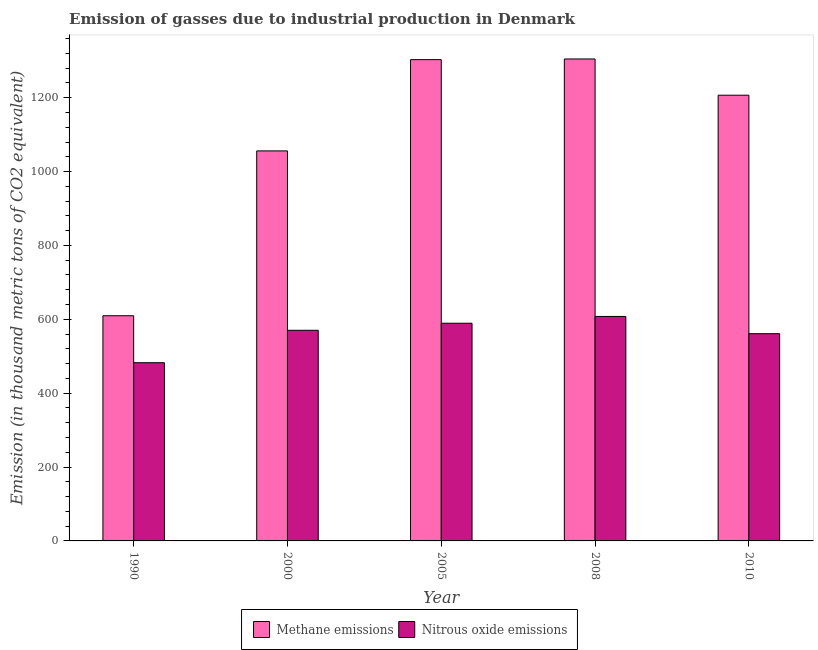How many different coloured bars are there?
Offer a very short reply. 2. How many groups of bars are there?
Make the answer very short. 5. Are the number of bars per tick equal to the number of legend labels?
Keep it short and to the point. Yes. How many bars are there on the 2nd tick from the left?
Provide a succinct answer. 2. What is the label of the 3rd group of bars from the left?
Give a very brief answer. 2005. What is the amount of methane emissions in 2010?
Provide a succinct answer. 1206.8. Across all years, what is the maximum amount of methane emissions?
Your response must be concise. 1304.9. Across all years, what is the minimum amount of nitrous oxide emissions?
Offer a very short reply. 482.5. In which year was the amount of methane emissions minimum?
Offer a very short reply. 1990. What is the total amount of nitrous oxide emissions in the graph?
Offer a very short reply. 2811.1. What is the difference between the amount of nitrous oxide emissions in 2005 and that in 2010?
Make the answer very short. 28.3. What is the difference between the amount of nitrous oxide emissions in 2000 and the amount of methane emissions in 2005?
Your response must be concise. -19.1. What is the average amount of methane emissions per year?
Your response must be concise. 1096.1. What is the ratio of the amount of methane emissions in 2000 to that in 2010?
Keep it short and to the point. 0.88. Is the amount of methane emissions in 2000 less than that in 2008?
Your answer should be very brief. Yes. Is the difference between the amount of nitrous oxide emissions in 1990 and 2008 greater than the difference between the amount of methane emissions in 1990 and 2008?
Ensure brevity in your answer.  No. What is the difference between the highest and the second highest amount of nitrous oxide emissions?
Your response must be concise. 18.4. What is the difference between the highest and the lowest amount of methane emissions?
Offer a very short reply. 695.2. In how many years, is the amount of nitrous oxide emissions greater than the average amount of nitrous oxide emissions taken over all years?
Provide a short and direct response. 3. Is the sum of the amount of nitrous oxide emissions in 2000 and 2008 greater than the maximum amount of methane emissions across all years?
Provide a succinct answer. Yes. What does the 2nd bar from the left in 2000 represents?
Ensure brevity in your answer.  Nitrous oxide emissions. What does the 2nd bar from the right in 2010 represents?
Offer a very short reply. Methane emissions. How many bars are there?
Make the answer very short. 10. What is the difference between two consecutive major ticks on the Y-axis?
Your answer should be very brief. 200. Are the values on the major ticks of Y-axis written in scientific E-notation?
Your answer should be very brief. No. Does the graph contain any zero values?
Your response must be concise. No. Does the graph contain grids?
Offer a very short reply. No. Where does the legend appear in the graph?
Give a very brief answer. Bottom center. What is the title of the graph?
Offer a terse response. Emission of gasses due to industrial production in Denmark. What is the label or title of the Y-axis?
Provide a short and direct response. Emission (in thousand metric tons of CO2 equivalent). What is the Emission (in thousand metric tons of CO2 equivalent) of Methane emissions in 1990?
Your answer should be very brief. 609.7. What is the Emission (in thousand metric tons of CO2 equivalent) in Nitrous oxide emissions in 1990?
Offer a very short reply. 482.5. What is the Emission (in thousand metric tons of CO2 equivalent) of Methane emissions in 2000?
Offer a very short reply. 1056. What is the Emission (in thousand metric tons of CO2 equivalent) in Nitrous oxide emissions in 2000?
Your answer should be very brief. 570.3. What is the Emission (in thousand metric tons of CO2 equivalent) in Methane emissions in 2005?
Offer a terse response. 1303.1. What is the Emission (in thousand metric tons of CO2 equivalent) of Nitrous oxide emissions in 2005?
Your response must be concise. 589.4. What is the Emission (in thousand metric tons of CO2 equivalent) in Methane emissions in 2008?
Give a very brief answer. 1304.9. What is the Emission (in thousand metric tons of CO2 equivalent) in Nitrous oxide emissions in 2008?
Provide a succinct answer. 607.8. What is the Emission (in thousand metric tons of CO2 equivalent) of Methane emissions in 2010?
Your answer should be very brief. 1206.8. What is the Emission (in thousand metric tons of CO2 equivalent) of Nitrous oxide emissions in 2010?
Provide a short and direct response. 561.1. Across all years, what is the maximum Emission (in thousand metric tons of CO2 equivalent) of Methane emissions?
Provide a short and direct response. 1304.9. Across all years, what is the maximum Emission (in thousand metric tons of CO2 equivalent) in Nitrous oxide emissions?
Your answer should be compact. 607.8. Across all years, what is the minimum Emission (in thousand metric tons of CO2 equivalent) in Methane emissions?
Make the answer very short. 609.7. Across all years, what is the minimum Emission (in thousand metric tons of CO2 equivalent) of Nitrous oxide emissions?
Provide a short and direct response. 482.5. What is the total Emission (in thousand metric tons of CO2 equivalent) of Methane emissions in the graph?
Make the answer very short. 5480.5. What is the total Emission (in thousand metric tons of CO2 equivalent) of Nitrous oxide emissions in the graph?
Offer a very short reply. 2811.1. What is the difference between the Emission (in thousand metric tons of CO2 equivalent) of Methane emissions in 1990 and that in 2000?
Give a very brief answer. -446.3. What is the difference between the Emission (in thousand metric tons of CO2 equivalent) of Nitrous oxide emissions in 1990 and that in 2000?
Give a very brief answer. -87.8. What is the difference between the Emission (in thousand metric tons of CO2 equivalent) in Methane emissions in 1990 and that in 2005?
Your answer should be compact. -693.4. What is the difference between the Emission (in thousand metric tons of CO2 equivalent) in Nitrous oxide emissions in 1990 and that in 2005?
Provide a short and direct response. -106.9. What is the difference between the Emission (in thousand metric tons of CO2 equivalent) of Methane emissions in 1990 and that in 2008?
Offer a terse response. -695.2. What is the difference between the Emission (in thousand metric tons of CO2 equivalent) of Nitrous oxide emissions in 1990 and that in 2008?
Your answer should be very brief. -125.3. What is the difference between the Emission (in thousand metric tons of CO2 equivalent) of Methane emissions in 1990 and that in 2010?
Offer a very short reply. -597.1. What is the difference between the Emission (in thousand metric tons of CO2 equivalent) in Nitrous oxide emissions in 1990 and that in 2010?
Give a very brief answer. -78.6. What is the difference between the Emission (in thousand metric tons of CO2 equivalent) in Methane emissions in 2000 and that in 2005?
Keep it short and to the point. -247.1. What is the difference between the Emission (in thousand metric tons of CO2 equivalent) of Nitrous oxide emissions in 2000 and that in 2005?
Give a very brief answer. -19.1. What is the difference between the Emission (in thousand metric tons of CO2 equivalent) of Methane emissions in 2000 and that in 2008?
Keep it short and to the point. -248.9. What is the difference between the Emission (in thousand metric tons of CO2 equivalent) of Nitrous oxide emissions in 2000 and that in 2008?
Offer a very short reply. -37.5. What is the difference between the Emission (in thousand metric tons of CO2 equivalent) of Methane emissions in 2000 and that in 2010?
Keep it short and to the point. -150.8. What is the difference between the Emission (in thousand metric tons of CO2 equivalent) in Nitrous oxide emissions in 2000 and that in 2010?
Your response must be concise. 9.2. What is the difference between the Emission (in thousand metric tons of CO2 equivalent) of Nitrous oxide emissions in 2005 and that in 2008?
Provide a succinct answer. -18.4. What is the difference between the Emission (in thousand metric tons of CO2 equivalent) of Methane emissions in 2005 and that in 2010?
Your answer should be very brief. 96.3. What is the difference between the Emission (in thousand metric tons of CO2 equivalent) in Nitrous oxide emissions in 2005 and that in 2010?
Provide a succinct answer. 28.3. What is the difference between the Emission (in thousand metric tons of CO2 equivalent) in Methane emissions in 2008 and that in 2010?
Your answer should be compact. 98.1. What is the difference between the Emission (in thousand metric tons of CO2 equivalent) of Nitrous oxide emissions in 2008 and that in 2010?
Your answer should be compact. 46.7. What is the difference between the Emission (in thousand metric tons of CO2 equivalent) of Methane emissions in 1990 and the Emission (in thousand metric tons of CO2 equivalent) of Nitrous oxide emissions in 2000?
Provide a short and direct response. 39.4. What is the difference between the Emission (in thousand metric tons of CO2 equivalent) of Methane emissions in 1990 and the Emission (in thousand metric tons of CO2 equivalent) of Nitrous oxide emissions in 2005?
Your answer should be compact. 20.3. What is the difference between the Emission (in thousand metric tons of CO2 equivalent) in Methane emissions in 1990 and the Emission (in thousand metric tons of CO2 equivalent) in Nitrous oxide emissions in 2010?
Keep it short and to the point. 48.6. What is the difference between the Emission (in thousand metric tons of CO2 equivalent) of Methane emissions in 2000 and the Emission (in thousand metric tons of CO2 equivalent) of Nitrous oxide emissions in 2005?
Provide a short and direct response. 466.6. What is the difference between the Emission (in thousand metric tons of CO2 equivalent) in Methane emissions in 2000 and the Emission (in thousand metric tons of CO2 equivalent) in Nitrous oxide emissions in 2008?
Offer a very short reply. 448.2. What is the difference between the Emission (in thousand metric tons of CO2 equivalent) in Methane emissions in 2000 and the Emission (in thousand metric tons of CO2 equivalent) in Nitrous oxide emissions in 2010?
Your answer should be very brief. 494.9. What is the difference between the Emission (in thousand metric tons of CO2 equivalent) of Methane emissions in 2005 and the Emission (in thousand metric tons of CO2 equivalent) of Nitrous oxide emissions in 2008?
Your answer should be compact. 695.3. What is the difference between the Emission (in thousand metric tons of CO2 equivalent) in Methane emissions in 2005 and the Emission (in thousand metric tons of CO2 equivalent) in Nitrous oxide emissions in 2010?
Offer a terse response. 742. What is the difference between the Emission (in thousand metric tons of CO2 equivalent) of Methane emissions in 2008 and the Emission (in thousand metric tons of CO2 equivalent) of Nitrous oxide emissions in 2010?
Provide a short and direct response. 743.8. What is the average Emission (in thousand metric tons of CO2 equivalent) in Methane emissions per year?
Offer a terse response. 1096.1. What is the average Emission (in thousand metric tons of CO2 equivalent) in Nitrous oxide emissions per year?
Your answer should be very brief. 562.22. In the year 1990, what is the difference between the Emission (in thousand metric tons of CO2 equivalent) in Methane emissions and Emission (in thousand metric tons of CO2 equivalent) in Nitrous oxide emissions?
Offer a very short reply. 127.2. In the year 2000, what is the difference between the Emission (in thousand metric tons of CO2 equivalent) of Methane emissions and Emission (in thousand metric tons of CO2 equivalent) of Nitrous oxide emissions?
Offer a very short reply. 485.7. In the year 2005, what is the difference between the Emission (in thousand metric tons of CO2 equivalent) in Methane emissions and Emission (in thousand metric tons of CO2 equivalent) in Nitrous oxide emissions?
Ensure brevity in your answer.  713.7. In the year 2008, what is the difference between the Emission (in thousand metric tons of CO2 equivalent) in Methane emissions and Emission (in thousand metric tons of CO2 equivalent) in Nitrous oxide emissions?
Keep it short and to the point. 697.1. In the year 2010, what is the difference between the Emission (in thousand metric tons of CO2 equivalent) in Methane emissions and Emission (in thousand metric tons of CO2 equivalent) in Nitrous oxide emissions?
Your response must be concise. 645.7. What is the ratio of the Emission (in thousand metric tons of CO2 equivalent) of Methane emissions in 1990 to that in 2000?
Give a very brief answer. 0.58. What is the ratio of the Emission (in thousand metric tons of CO2 equivalent) in Nitrous oxide emissions in 1990 to that in 2000?
Give a very brief answer. 0.85. What is the ratio of the Emission (in thousand metric tons of CO2 equivalent) of Methane emissions in 1990 to that in 2005?
Ensure brevity in your answer.  0.47. What is the ratio of the Emission (in thousand metric tons of CO2 equivalent) in Nitrous oxide emissions in 1990 to that in 2005?
Provide a short and direct response. 0.82. What is the ratio of the Emission (in thousand metric tons of CO2 equivalent) in Methane emissions in 1990 to that in 2008?
Provide a short and direct response. 0.47. What is the ratio of the Emission (in thousand metric tons of CO2 equivalent) in Nitrous oxide emissions in 1990 to that in 2008?
Offer a very short reply. 0.79. What is the ratio of the Emission (in thousand metric tons of CO2 equivalent) in Methane emissions in 1990 to that in 2010?
Provide a succinct answer. 0.51. What is the ratio of the Emission (in thousand metric tons of CO2 equivalent) of Nitrous oxide emissions in 1990 to that in 2010?
Offer a terse response. 0.86. What is the ratio of the Emission (in thousand metric tons of CO2 equivalent) in Methane emissions in 2000 to that in 2005?
Provide a short and direct response. 0.81. What is the ratio of the Emission (in thousand metric tons of CO2 equivalent) in Nitrous oxide emissions in 2000 to that in 2005?
Give a very brief answer. 0.97. What is the ratio of the Emission (in thousand metric tons of CO2 equivalent) of Methane emissions in 2000 to that in 2008?
Your answer should be very brief. 0.81. What is the ratio of the Emission (in thousand metric tons of CO2 equivalent) of Nitrous oxide emissions in 2000 to that in 2008?
Ensure brevity in your answer.  0.94. What is the ratio of the Emission (in thousand metric tons of CO2 equivalent) in Methane emissions in 2000 to that in 2010?
Provide a short and direct response. 0.88. What is the ratio of the Emission (in thousand metric tons of CO2 equivalent) in Nitrous oxide emissions in 2000 to that in 2010?
Make the answer very short. 1.02. What is the ratio of the Emission (in thousand metric tons of CO2 equivalent) in Methane emissions in 2005 to that in 2008?
Provide a short and direct response. 1. What is the ratio of the Emission (in thousand metric tons of CO2 equivalent) of Nitrous oxide emissions in 2005 to that in 2008?
Offer a terse response. 0.97. What is the ratio of the Emission (in thousand metric tons of CO2 equivalent) in Methane emissions in 2005 to that in 2010?
Make the answer very short. 1.08. What is the ratio of the Emission (in thousand metric tons of CO2 equivalent) in Nitrous oxide emissions in 2005 to that in 2010?
Offer a terse response. 1.05. What is the ratio of the Emission (in thousand metric tons of CO2 equivalent) in Methane emissions in 2008 to that in 2010?
Ensure brevity in your answer.  1.08. What is the ratio of the Emission (in thousand metric tons of CO2 equivalent) in Nitrous oxide emissions in 2008 to that in 2010?
Offer a terse response. 1.08. What is the difference between the highest and the second highest Emission (in thousand metric tons of CO2 equivalent) in Methane emissions?
Keep it short and to the point. 1.8. What is the difference between the highest and the lowest Emission (in thousand metric tons of CO2 equivalent) in Methane emissions?
Offer a terse response. 695.2. What is the difference between the highest and the lowest Emission (in thousand metric tons of CO2 equivalent) in Nitrous oxide emissions?
Offer a terse response. 125.3. 